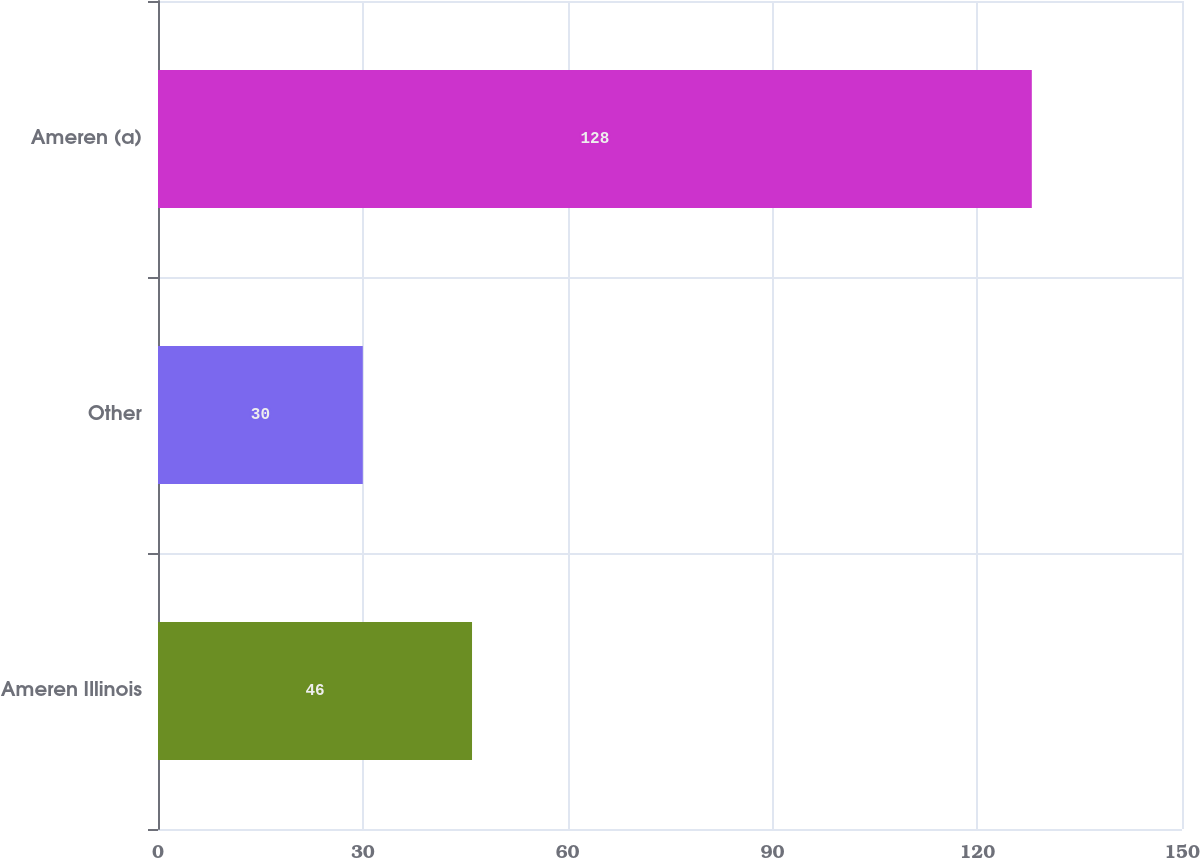<chart> <loc_0><loc_0><loc_500><loc_500><bar_chart><fcel>Ameren Illinois<fcel>Other<fcel>Ameren (a)<nl><fcel>46<fcel>30<fcel>128<nl></chart> 